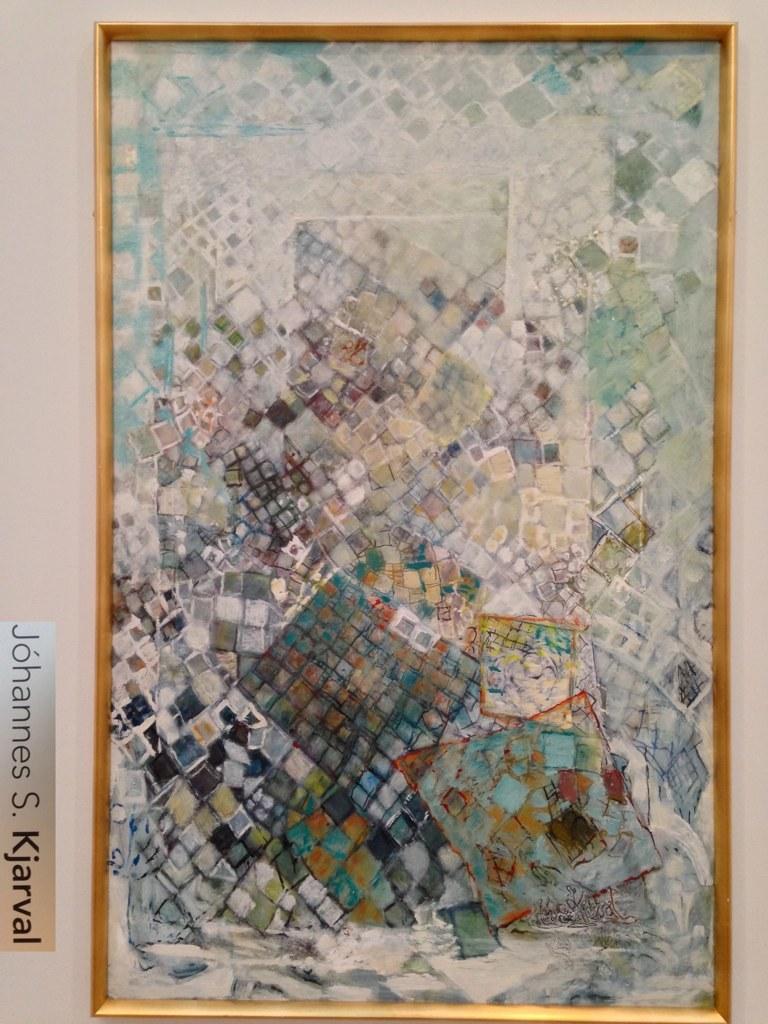What´s the name of the artist of this picture?
Make the answer very short. Johannes s. kjarval. 